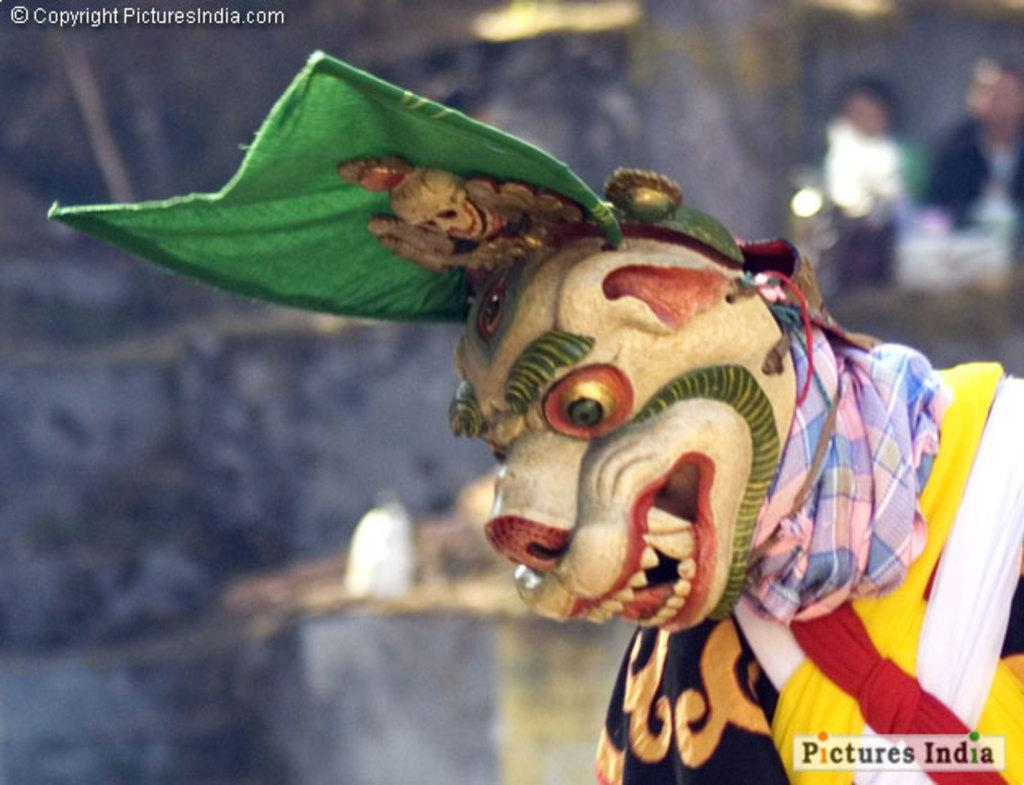What can be seen in the image related to clothing or attire? There is a costume in the image. How would you describe the background of the image? The background of the image is blurred. How many people are present in the image? There are two people in the image. Can you describe any text visible in the image? There is writing at the top and bottom of the image. What type of cloud is floating above the people in the image? There is no cloud visible in the image; the background is blurred. 